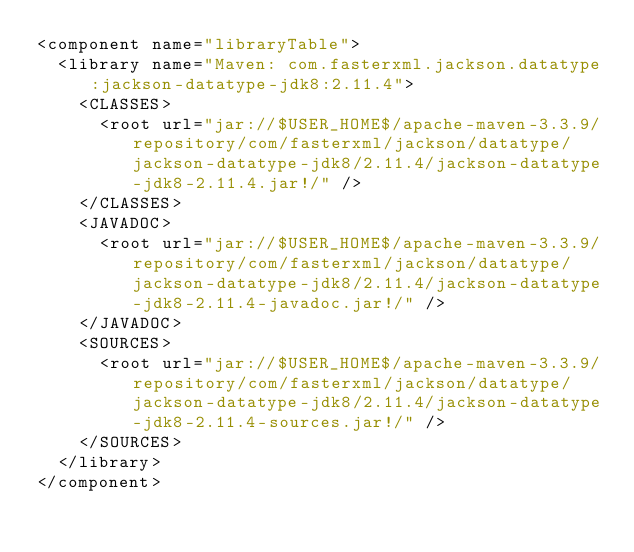Convert code to text. <code><loc_0><loc_0><loc_500><loc_500><_XML_><component name="libraryTable">
  <library name="Maven: com.fasterxml.jackson.datatype:jackson-datatype-jdk8:2.11.4">
    <CLASSES>
      <root url="jar://$USER_HOME$/apache-maven-3.3.9/repository/com/fasterxml/jackson/datatype/jackson-datatype-jdk8/2.11.4/jackson-datatype-jdk8-2.11.4.jar!/" />
    </CLASSES>
    <JAVADOC>
      <root url="jar://$USER_HOME$/apache-maven-3.3.9/repository/com/fasterxml/jackson/datatype/jackson-datatype-jdk8/2.11.4/jackson-datatype-jdk8-2.11.4-javadoc.jar!/" />
    </JAVADOC>
    <SOURCES>
      <root url="jar://$USER_HOME$/apache-maven-3.3.9/repository/com/fasterxml/jackson/datatype/jackson-datatype-jdk8/2.11.4/jackson-datatype-jdk8-2.11.4-sources.jar!/" />
    </SOURCES>
  </library>
</component></code> 